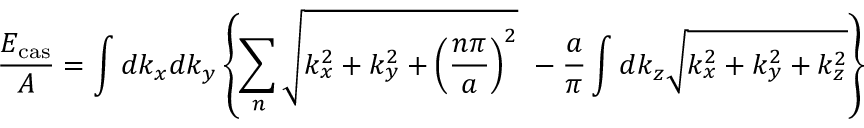Convert formula to latex. <formula><loc_0><loc_0><loc_500><loc_500>\frac { E _ { c a s } } { A } = \int d k _ { x } d k _ { y } \left \{ \sum _ { n } \sqrt { k _ { x } ^ { 2 } + k _ { y } ^ { 2 } + \left ( \frac { n \pi } { a } \right ) ^ { 2 } } - \frac { a } { \pi } \int d k _ { z } \sqrt { k _ { x } ^ { 2 } + k _ { y } ^ { 2 } + k _ { z } ^ { 2 } } \right \}</formula> 